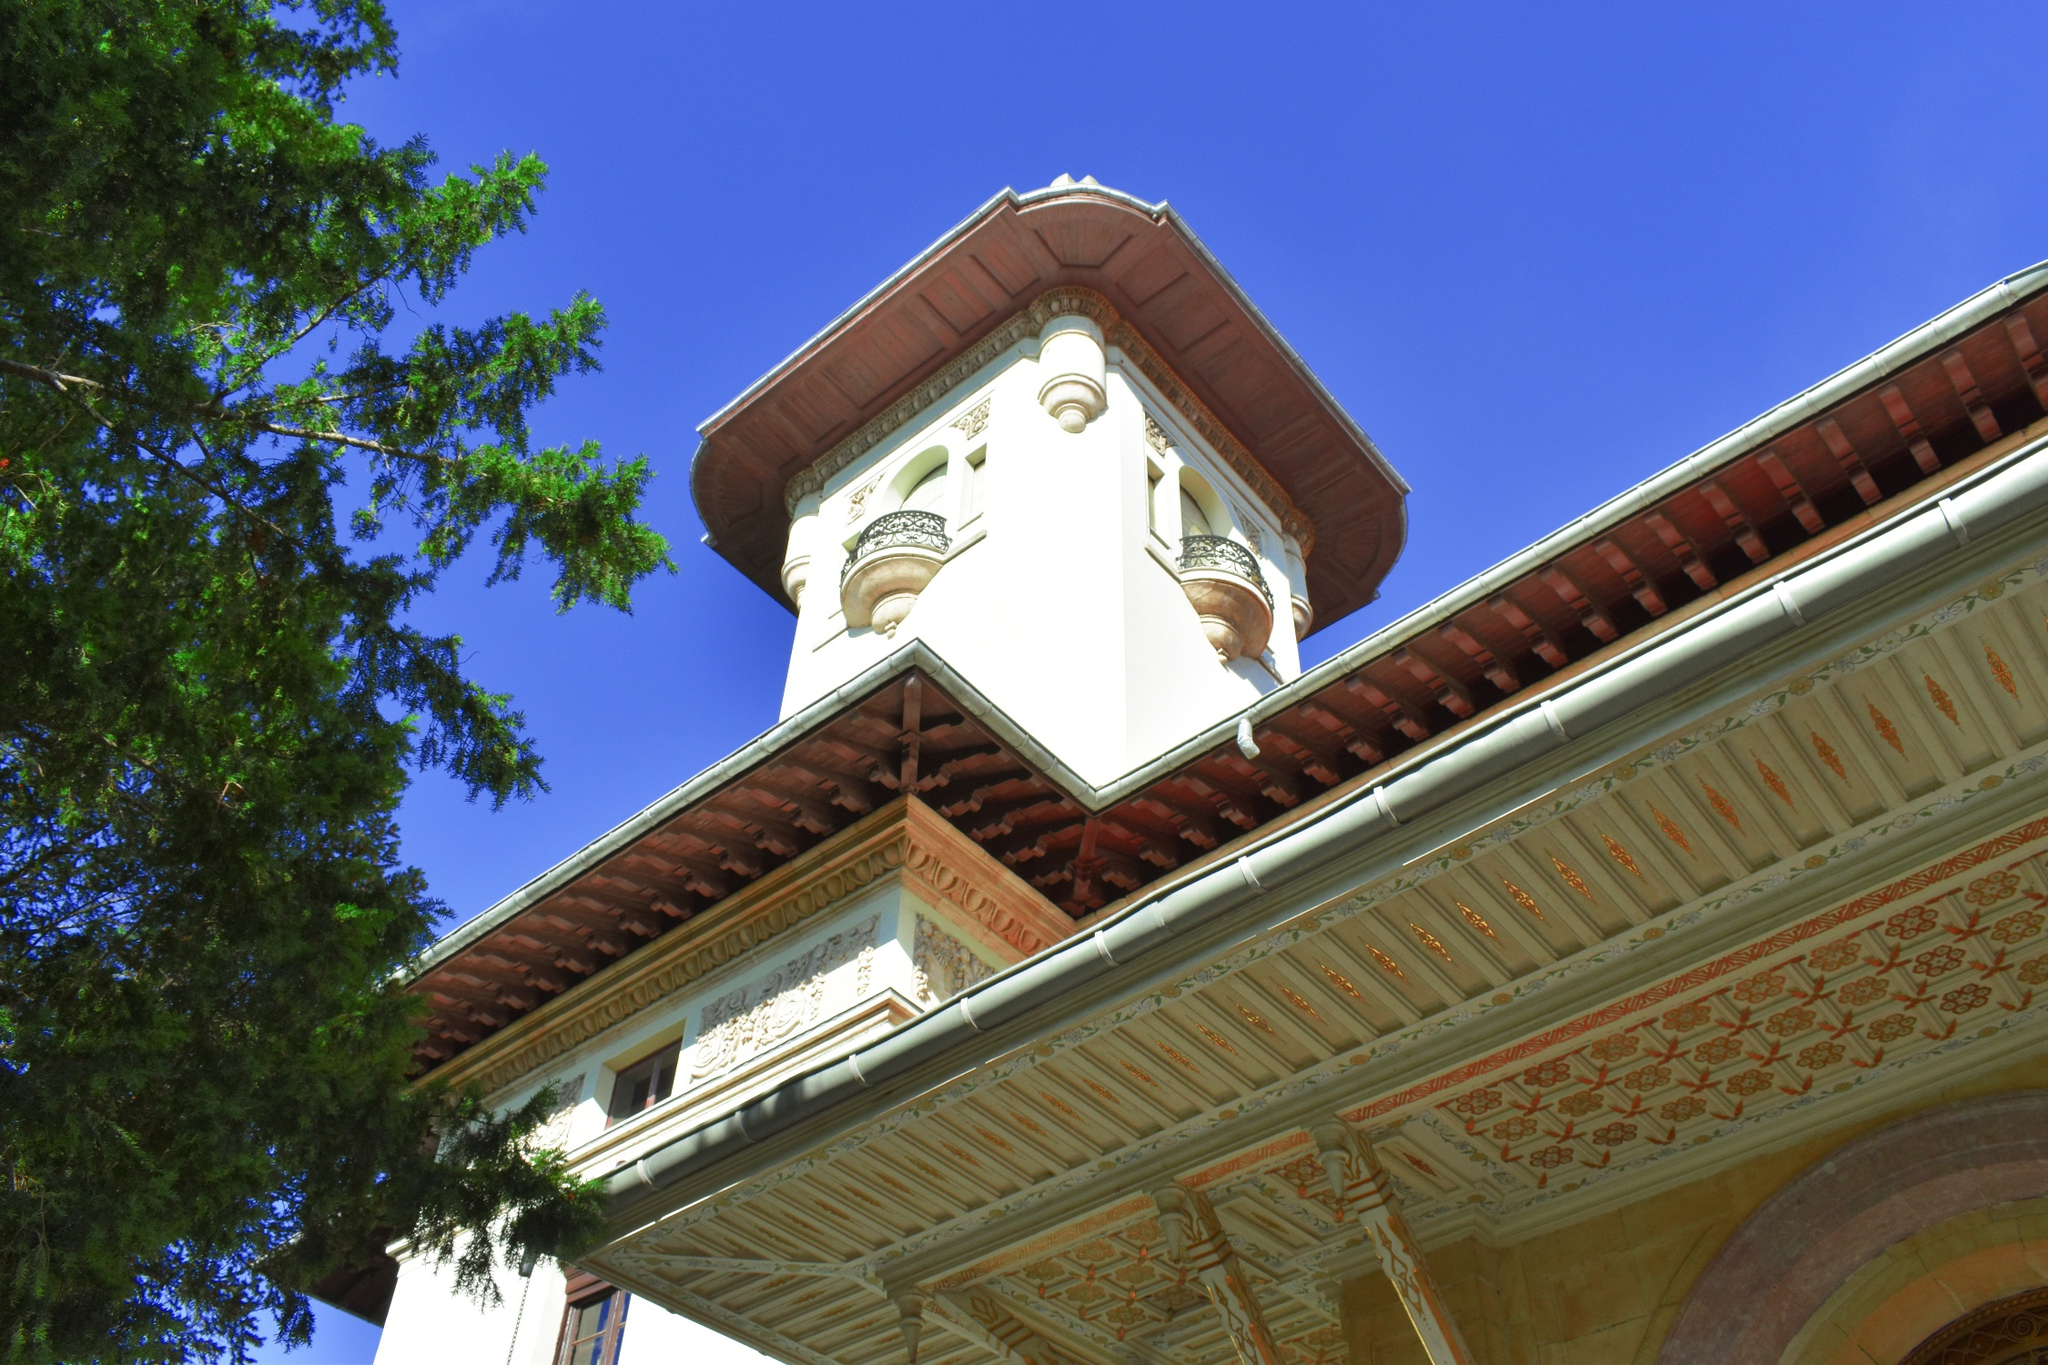What historical period or architectural style does this building represent? The intricate design details, ornate patterns, and the overall grandeur of the building suggest that it might belong to a historical period rich in artistic embellishments, possibly from the late 19th or early 20th century. The architectural style seems to embody elements of Neoclassical and Baroque designs, with its grandiose structure, arched windows, and decorative elements that emphasize luxury and sophistication. The vibrant red roof contrasting with the white walls also hints at influences from Southern European architecture, where such color schemes were commonly employed to create visually striking facades. Imagine the stories this tower could tell if it could speak. If this tower could speak, it would narrate tales of grandeur and history, witnessing countless events through the ages. It would recount the days when it was constructed, the meticulous craftsmanship that went into every ornate detail, and the admiration it received from everyone who beheld its beauty. The tower has likely witnessed numerous sunsets, watched over the changing seasons, and stood strong against the test of time. It would tell stories of people who found refuge within its walls, events celebrated in its shadow, and perhaps even secrets whispered in its balconies under the cover of the night. The tower stands as a silent guardian of history, holding within its walls a tapestry of human experiences woven across time. 